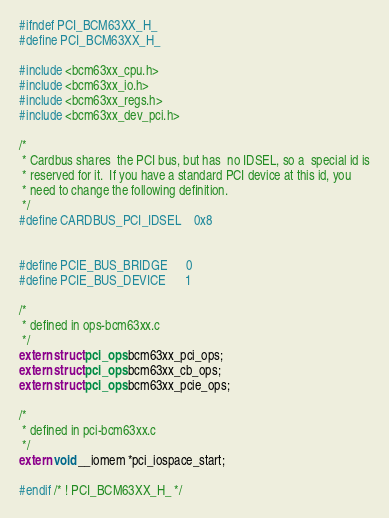Convert code to text. <code><loc_0><loc_0><loc_500><loc_500><_C_>#ifndef PCI_BCM63XX_H_
#define PCI_BCM63XX_H_

#include <bcm63xx_cpu.h>
#include <bcm63xx_io.h>
#include <bcm63xx_regs.h>
#include <bcm63xx_dev_pci.h>

/*
 * Cardbus shares  the PCI bus, but has	 no IDSEL, so a	 special id is
 * reserved for it.  If you have a standard PCI device at this id, you
 * need to change the following definition.
 */
#define CARDBUS_PCI_IDSEL	0x8


#define PCIE_BUS_BRIDGE		0
#define PCIE_BUS_DEVICE		1

/*
 * defined in ops-bcm63xx.c
 */
extern struct pci_ops bcm63xx_pci_ops;
extern struct pci_ops bcm63xx_cb_ops;
extern struct pci_ops bcm63xx_pcie_ops;

/*
 * defined in pci-bcm63xx.c
 */
extern void __iomem *pci_iospace_start;

#endif /* ! PCI_BCM63XX_H_ */
</code> 